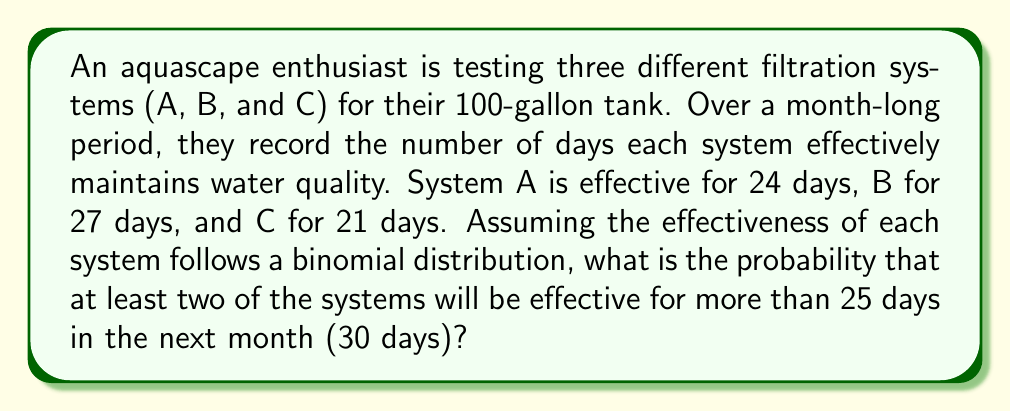Could you help me with this problem? Let's approach this step-by-step:

1) First, we need to calculate the probability of success (p) for each system:
   System A: $p_A = 24/30 = 0.8$
   System B: $p_B = 27/30 = 0.9$
   System C: $p_C = 21/30 = 0.7$

2) We want the probability of each system being effective for more than 25 days out of 30. This is equivalent to the probability of 26 or more successes in 30 trials.

3) We can calculate this using the cumulative binomial distribution:
   $P(X > 25) = 1 - P(X \leq 25)$

4) For each system:
   System A: $P(X_A > 25) = 1 - \sum_{k=0}^{25} \binom{30}{k}(0.8)^k(0.2)^{30-k} \approx 0.2963$
   System B: $P(X_B > 25) = 1 - \sum_{k=0}^{25} \binom{30}{k}(0.9)^k(0.1)^{30-k} \approx 0.7723$
   System C: $P(X_C > 25) = 1 - \sum_{k=0}^{25} \binom{30}{k}(0.7)^k(0.3)^{30-k} \approx 0.0461$

5) Now, we need to find the probability that at least two systems are effective for more than 25 days. This is equivalent to:
   $P(\text{at least 2}) = P(\text{all 3}) + P(\text{exactly 2})$

6) $P(\text{all 3}) = 0.2963 \times 0.7723 \times 0.0461 \approx 0.0105$

7) $P(\text{exactly 2}) = (0.2963 \times 0.7723 \times (1-0.0461)) + (0.2963 \times (1-0.7723) \times 0.0461) + ((1-0.2963) \times 0.7723 \times 0.0461) \approx 0.2181$

8) Therefore, $P(\text{at least 2}) = 0.0105 + 0.2181 = 0.2286$
Answer: 0.2286 